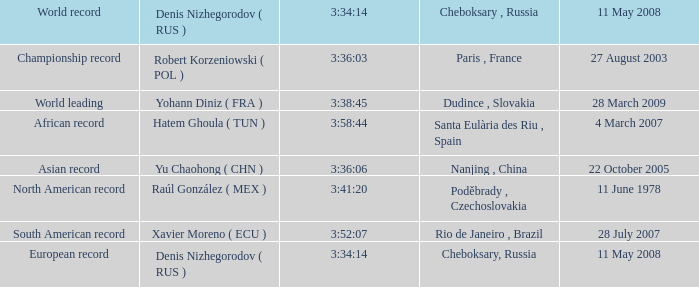When 3:38:45 is 3:34:14, what is the day on may 11th, 2008? 28 March 2009. 